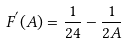Convert formula to latex. <formula><loc_0><loc_0><loc_500><loc_500>F ^ { ^ { \prime } } ( A ) = \frac { 1 } { 2 4 } - \frac { 1 } { 2 A }</formula> 